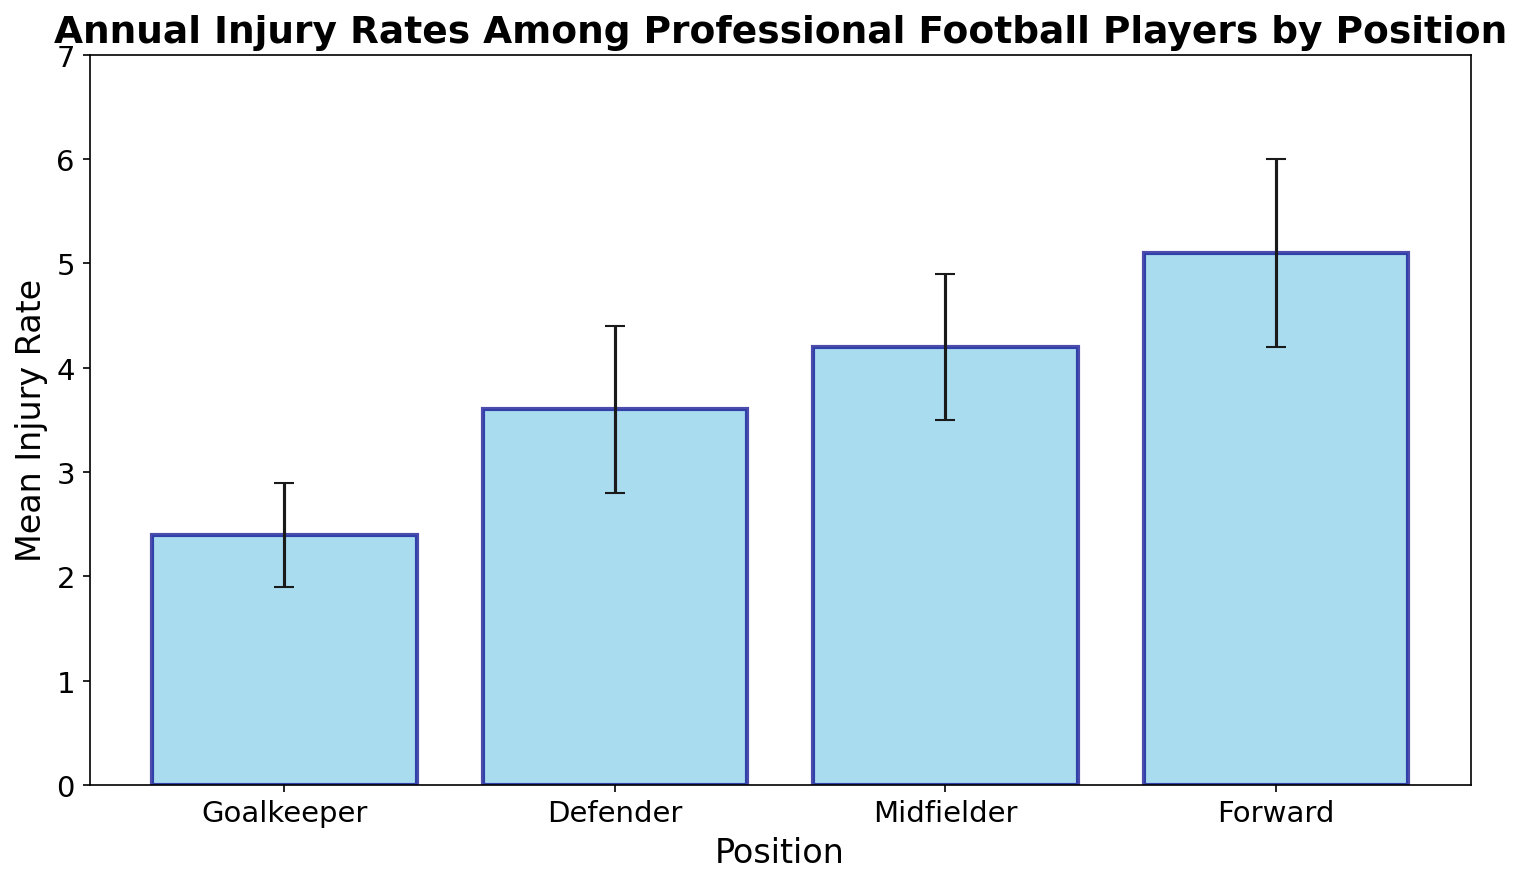Which position has the highest mean injury rate? The figure displays a bar for each position's mean injury rate with error bars, and the highest bar represents the highest mean injury rate.
Answer: Forward How does the midfielder's mean injury rate compare to the defender's mean injury rate? The mean injury rate for midfielders is represented by a bar that is higher than the bar for defenders. The midfielder's mean injury rate is 4.2, and the defender's mean injury rate is 3.6.
Answer: Midfielder's injury rate is higher What is the difference between the injury rates of goalkeepers and forwards? By looking at the heights of the bars for goalkeepers and forwards, subtract the goalkeeper's rate (2.4) from the forward's rate (5.1).
Answer: 2.7 Which position has the most variability in injury rates? The size of the error bars indicates variability. The forward position has the largest error bars, representing the highest standard deviation of 0.9.
Answer: Forward What’s the average mean injury rate across all positions? Sum the mean injury rates for all positions (2.4 + 3.6 + 4.2 + 5.1) and then divide by the number of positions (4).
Answer: 3.825 How much higher is the forward's mean injury rate compared to the goalkeeper's rate? Subtract the goalkeeper’s mean injury rate (2.4) from the forward’s mean rate (5.1): 5.1 - 2.4.
Answer: 2.7 What can you infer from the error bars about the consistency of injury rates among midfielders and defenders? Error bars show variation. Midfielders and defenders have relatively similar error bar sizes, indicating that their injury rates are comparably consistent.
Answer: Similar consistency Look at the title and infer which position you might prefer to play to minimize risk of injury. Referring to the title "Annual Injury Rates Among Professional Football Players by Position" and comparing bars, the goalkeeper has the lowest mean injury rate.
Answer: Goalkeeper Based on the bar heights, which two positions have the closest injury rates? Compare the heights of the bars; the defender's mean rate (3.6) and midfielder's mean rate (4.2) are closest to each other.
Answer: Defender and Midfielder 